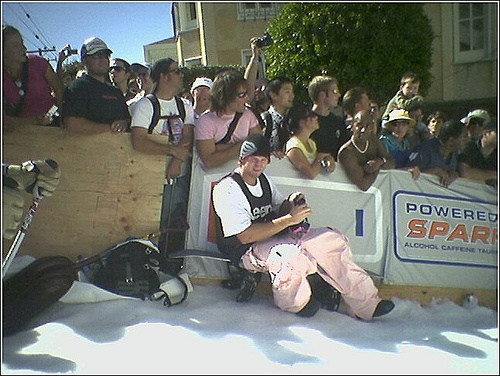Describe the objects in this image and their specific colors. I can see people in black, gray, and darkgray tones, people in black, lightgray, darkgray, and gray tones, people in black and gray tones, people in black, gray, and darkgray tones, and people in black and gray tones in this image. 